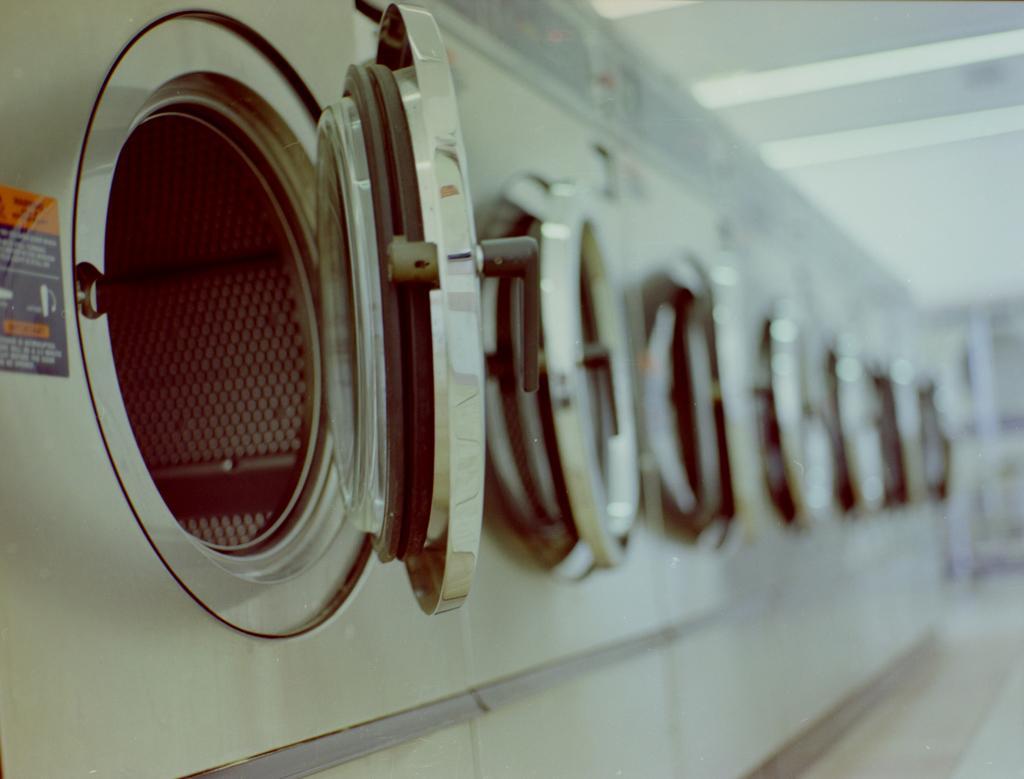Describe this image in one or two sentences. In this image I can see number of washing machines and I can see this image is little bit blurry from background. Here I can see black colour paper and on it I can see something is written. 